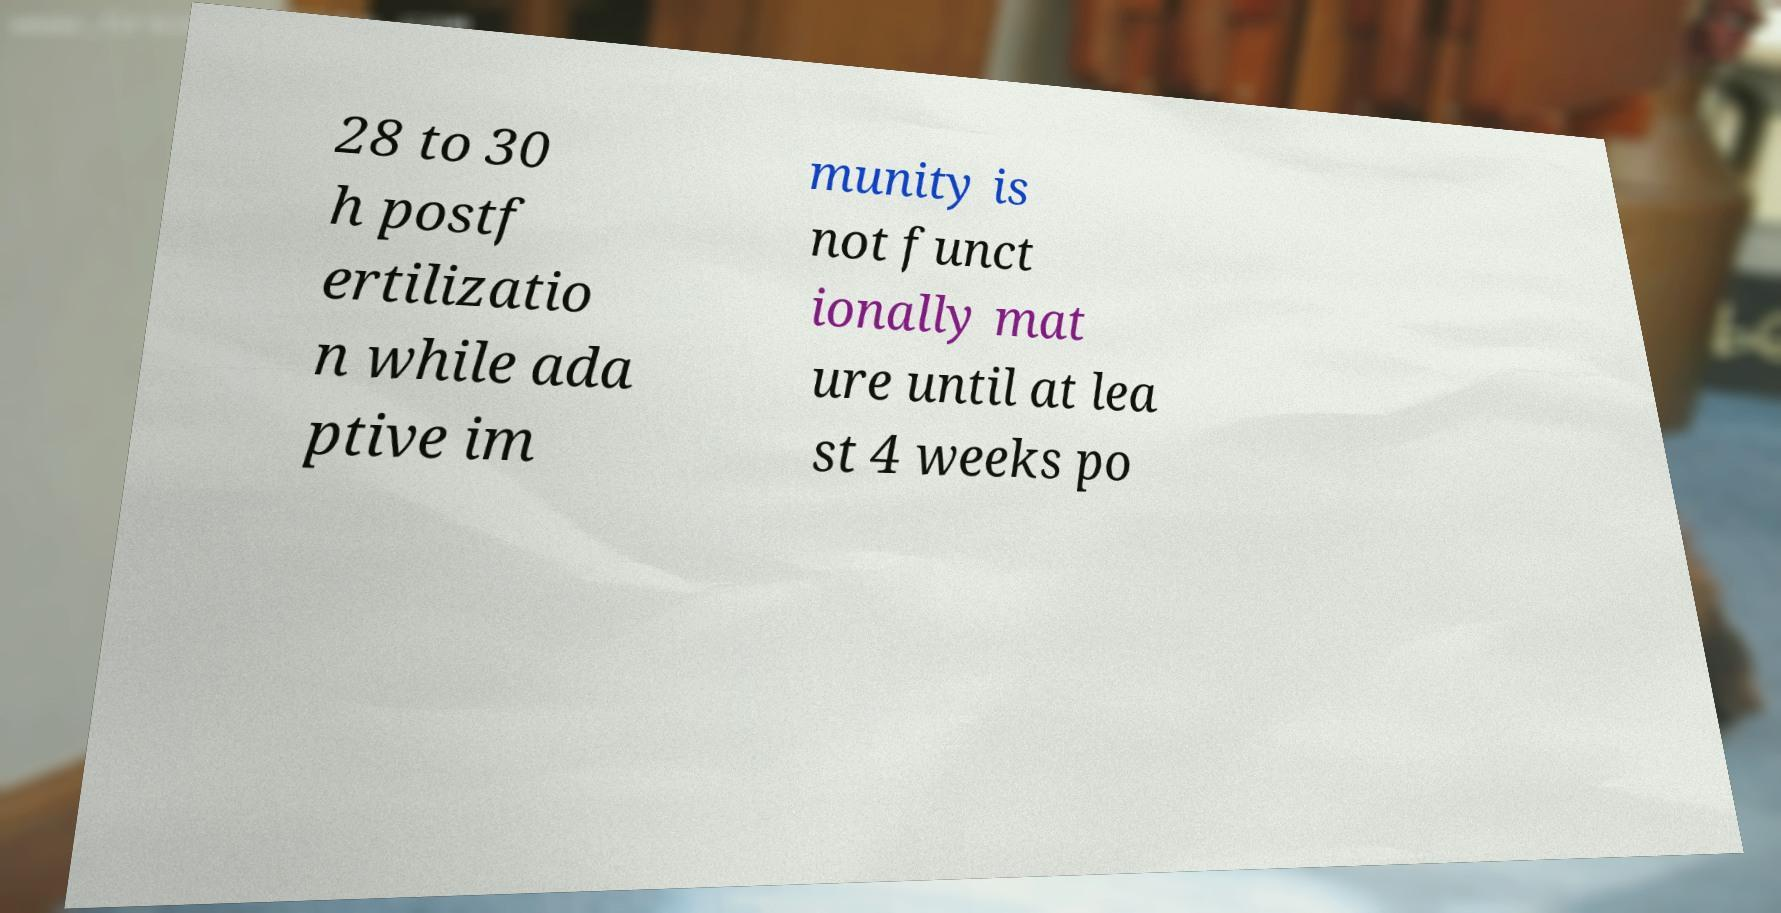Please identify and transcribe the text found in this image. 28 to 30 h postf ertilizatio n while ada ptive im munity is not funct ionally mat ure until at lea st 4 weeks po 